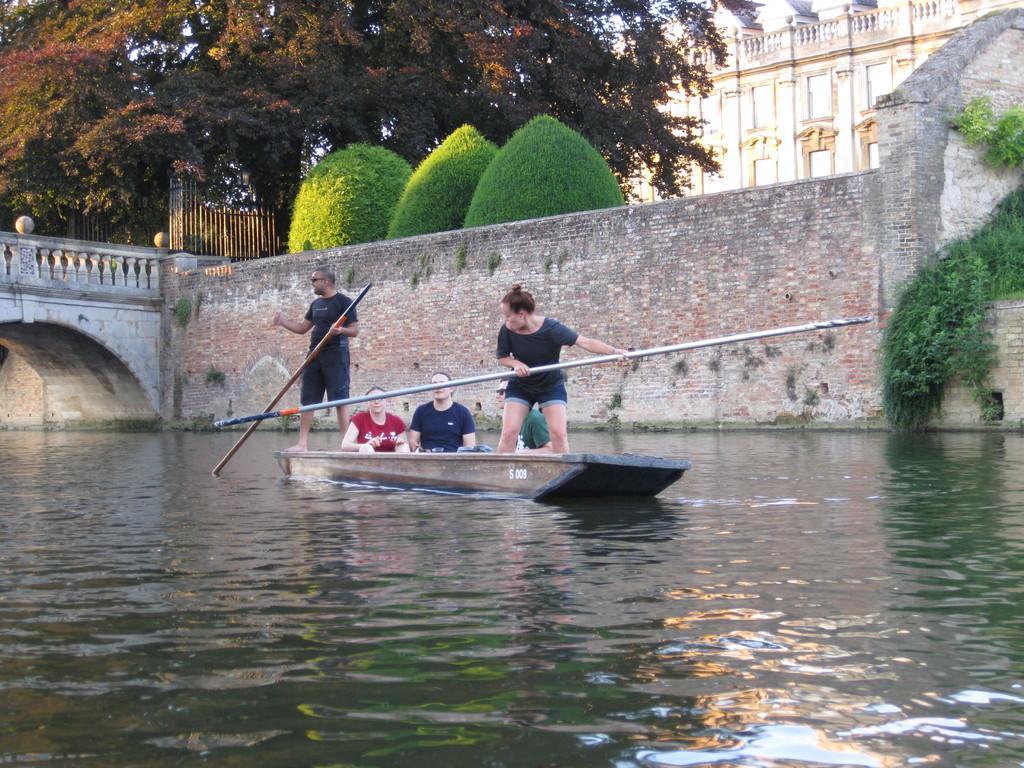Describe this image in one or two sentences. In the foreground of the picture there is a water body. In the center of the picture there is a boat, in the boat there are people, rowing. On the left there is a bridge. In the background there are trees, building, gate, creepers, wall and other objects. 